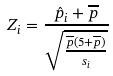<formula> <loc_0><loc_0><loc_500><loc_500>Z _ { i } = \frac { \hat { p } _ { i } + \overline { p } } { \sqrt { \frac { \overline { p } ( 5 + \overline { p } ) } { s _ { i } } } }</formula> 